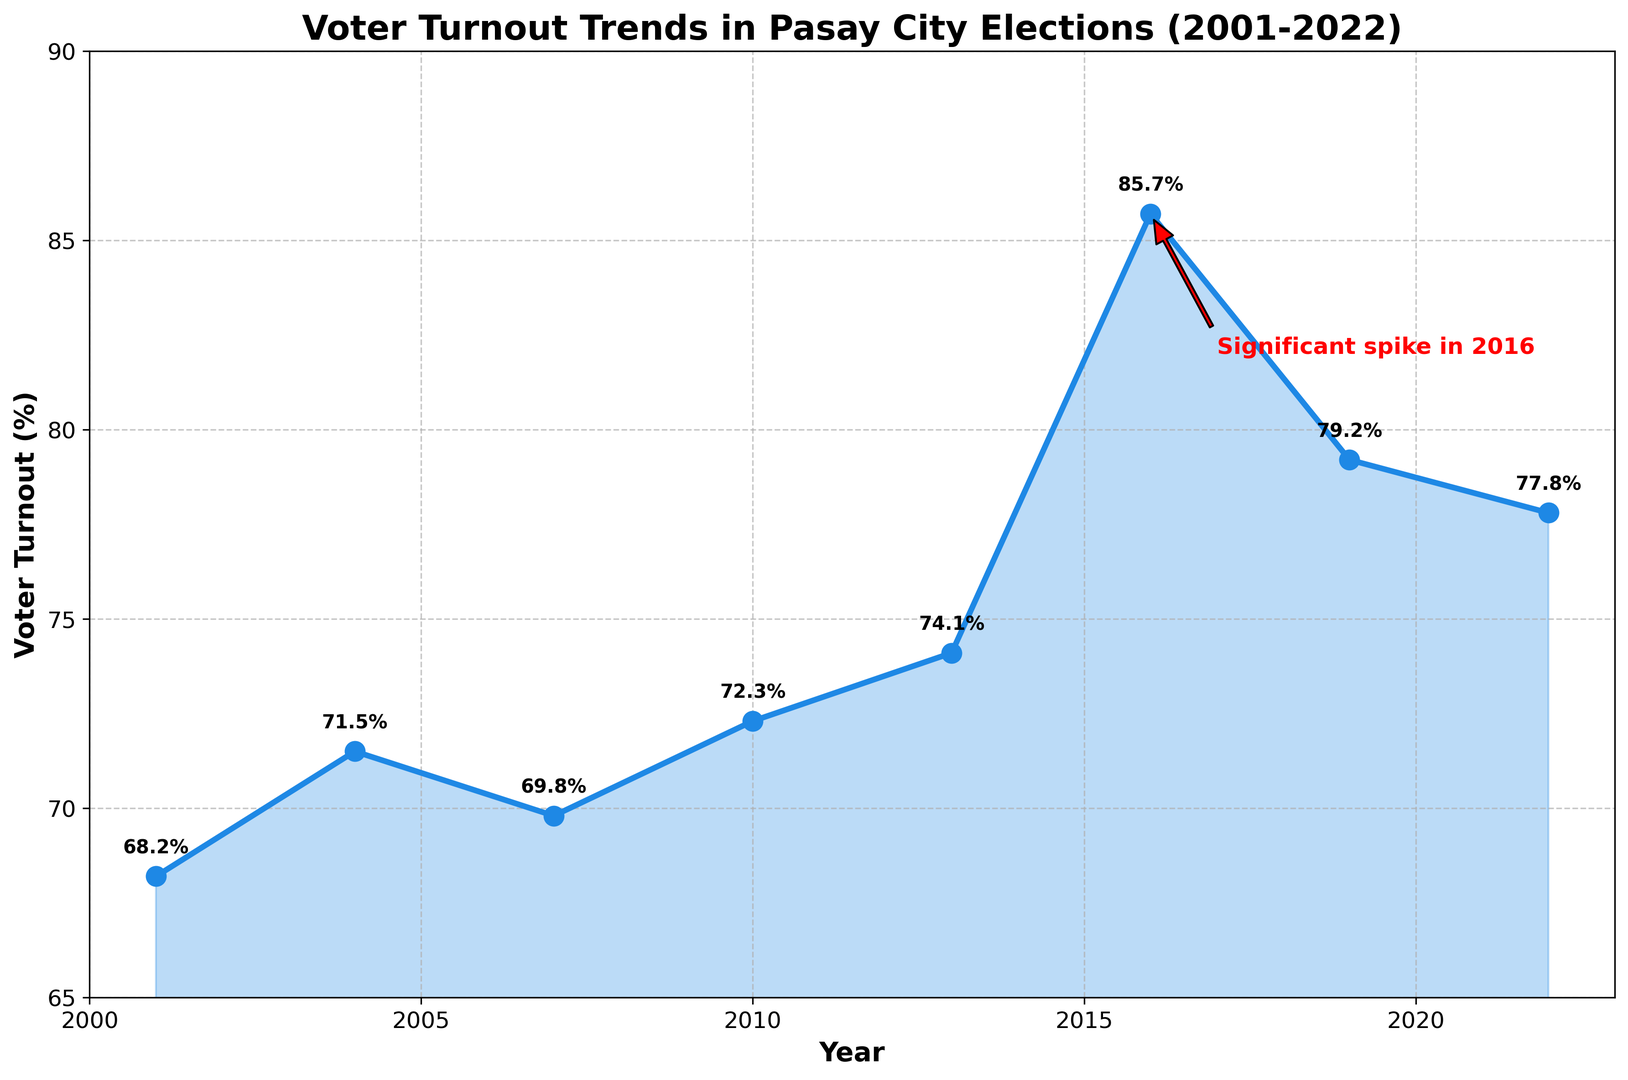What is the voter turnout percentage for the year 2016? The chart indicates a significant spike in voter turnout in 2016, and the annotation shows the exact percentage for that year.
Answer: 85.7% How does the voter turnout in 2019 compare to 2022? By examining the plot, the voter turnout for 2019 can be read as 79.2%, and for 2022, it is 77.8%.
Answer: Higher in 2019 What is the difference in voter turnout percentage between 2013 and 2016? The voter turnout in 2013 is 74.1%, and in 2016 it is 85.7%. Subtracting 74.1 from 85.7 gives the difference.
Answer: 11.6% Which year had the highest voter turnout? By inspecting the graph, the highest point is in 2016. The annotation confirms this with the highlighted spike.
Answer: 2016 What is the average voter turnout percentage from 2001 to 2022? Add up all the percentages and divide by the number of years: (68.2 + 71.5 + 69.8 + 72.3 + 74.1 + 85.7 + 79.2 + 77.8) / 8
Answer: 74.85% What trend can be observed in voter turnout from 2001 to 2010? Observing the graph from 2001 to 2010, the voter turnout shows a gradual increase.
Answer: Increasing Is the voter turnout percentage in 2004 greater than in 2007? Checking the values for 2004 and 2007, 2004 has 71.5% and 2007 has 69.8%.
Answer: Yes What happened to the voter turnout after 2016? Did it increase or decrease? After the significant spike in 2016 to 85.7%, the turnout decreased in 2019 to 79.2% and slightly again in 2022 to 77.8%.
Answer: Decreased How much did the voter turnout percentage increase from 2007 to 2010? The turnout in 2007 is 69.8% and in 2010 is 72.3%. Subtracting 69.8 from 72.3 gives the increase.
Answer: 2.5% By how much did the voter turnout percentage change between 2001 and 2004? The turnout in 2001 is 68.2%, and in 2004 it is 71.5%. Subtracting 68.2 from 71.5 gives the change.
Answer: 3.3% 